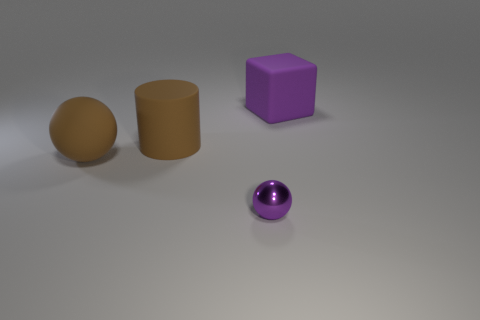Add 1 small green rubber spheres. How many objects exist? 5 Subtract all cylinders. How many objects are left? 3 Add 3 tiny objects. How many tiny objects exist? 4 Subtract 0 red blocks. How many objects are left? 4 Subtract all big cyan spheres. Subtract all large blocks. How many objects are left? 3 Add 4 metal spheres. How many metal spheres are left? 5 